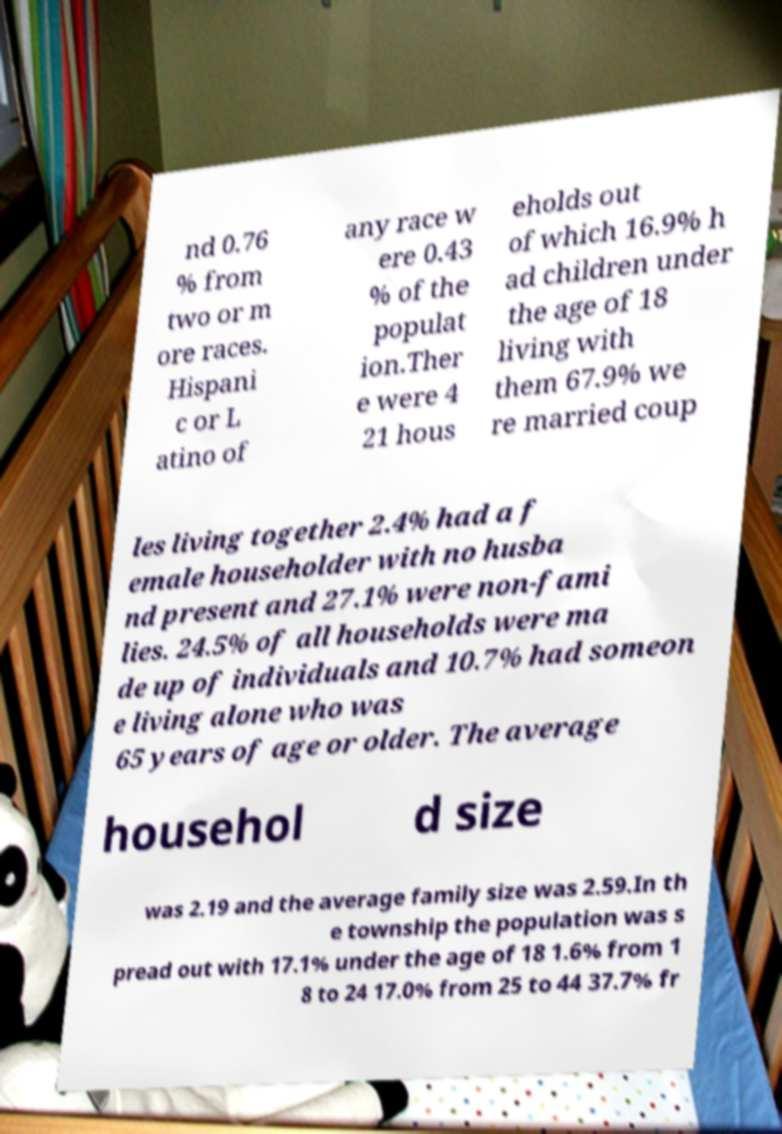I need the written content from this picture converted into text. Can you do that? nd 0.76 % from two or m ore races. Hispani c or L atino of any race w ere 0.43 % of the populat ion.Ther e were 4 21 hous eholds out of which 16.9% h ad children under the age of 18 living with them 67.9% we re married coup les living together 2.4% had a f emale householder with no husba nd present and 27.1% were non-fami lies. 24.5% of all households were ma de up of individuals and 10.7% had someon e living alone who was 65 years of age or older. The average househol d size was 2.19 and the average family size was 2.59.In th e township the population was s pread out with 17.1% under the age of 18 1.6% from 1 8 to 24 17.0% from 25 to 44 37.7% fr 